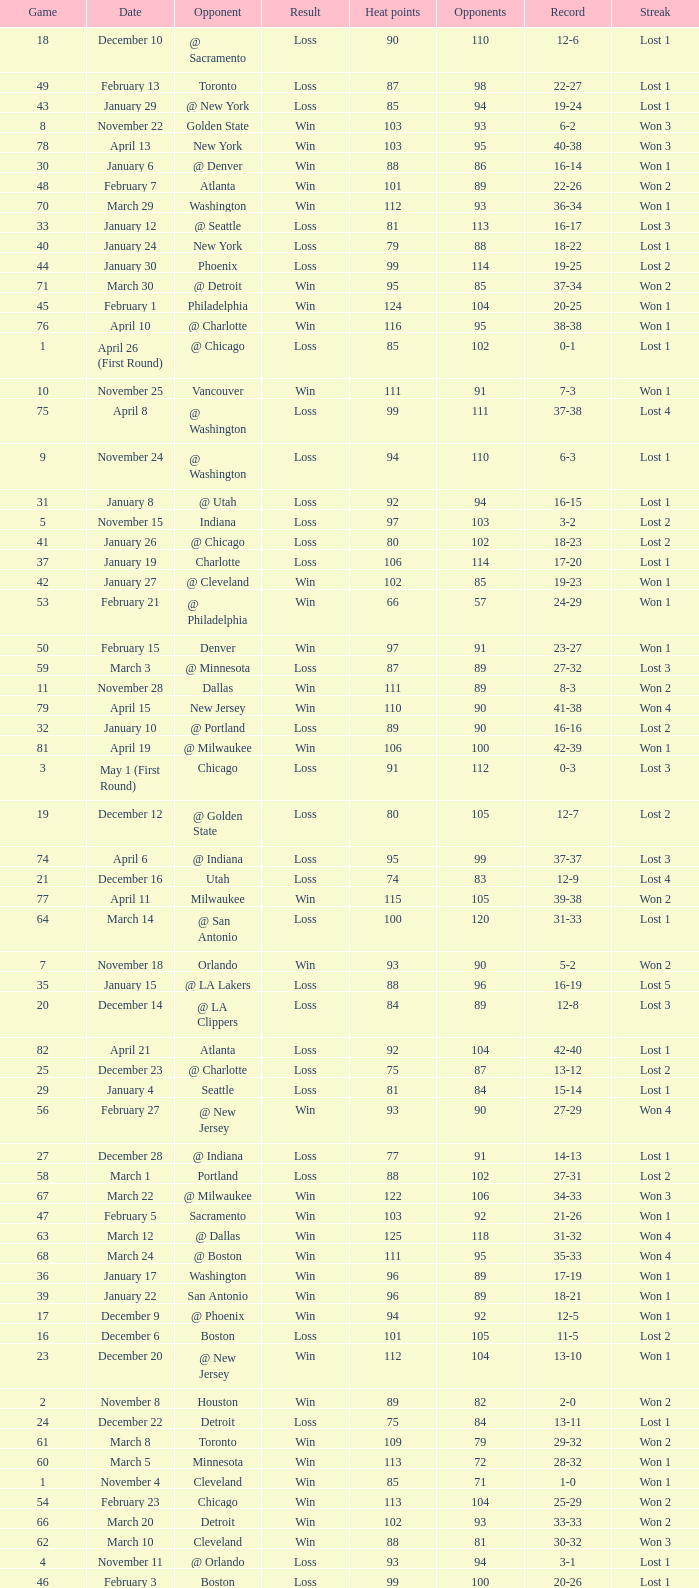What is Heat Points, when Game is less than 80, and when Date is "April 26 (First Round)"? 85.0. 